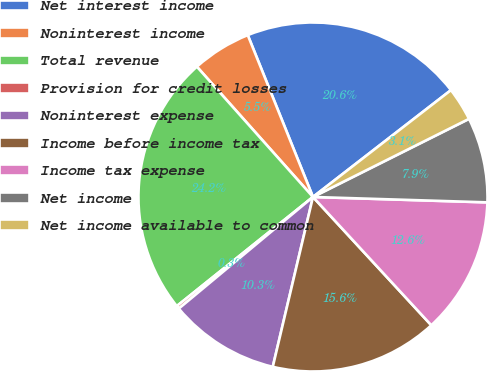Convert chart. <chart><loc_0><loc_0><loc_500><loc_500><pie_chart><fcel>Net interest income<fcel>Noninterest income<fcel>Total revenue<fcel>Provision for credit losses<fcel>Noninterest expense<fcel>Income before income tax<fcel>Income tax expense<fcel>Net income<fcel>Net income available to common<nl><fcel>20.61%<fcel>5.49%<fcel>24.17%<fcel>0.29%<fcel>10.26%<fcel>15.56%<fcel>12.65%<fcel>7.88%<fcel>3.1%<nl></chart> 